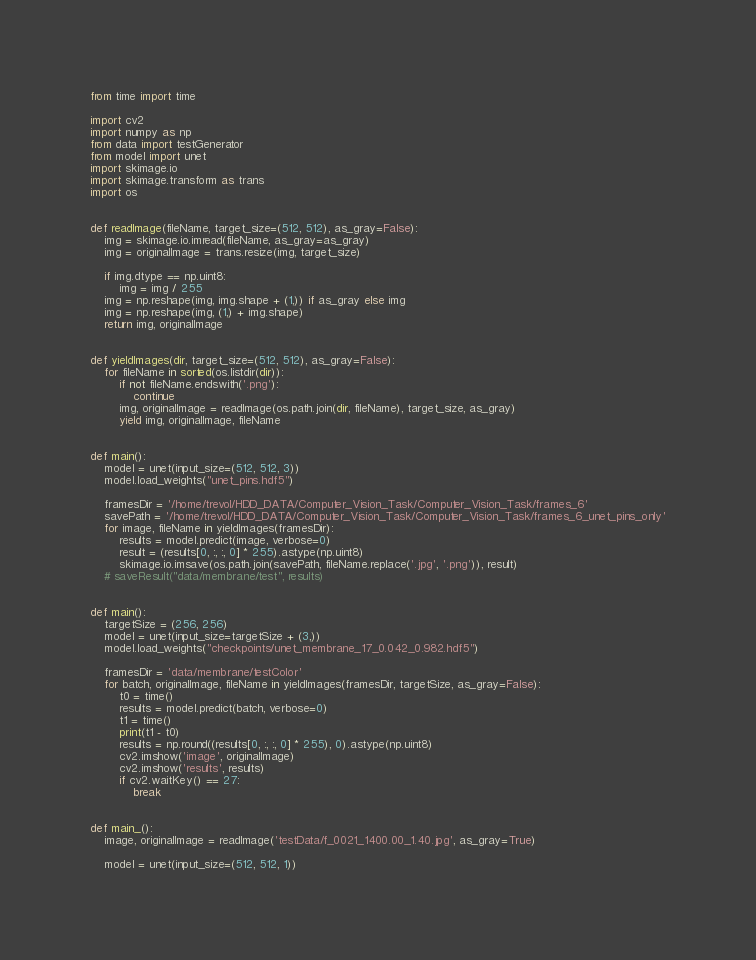Convert code to text. <code><loc_0><loc_0><loc_500><loc_500><_Python_>from time import time

import cv2
import numpy as np
from data import testGenerator
from model import unet
import skimage.io
import skimage.transform as trans
import os


def readImage(fileName, target_size=(512, 512), as_gray=False):
    img = skimage.io.imread(fileName, as_gray=as_gray)
    img = originalImage = trans.resize(img, target_size)

    if img.dtype == np.uint8:
        img = img / 255
    img = np.reshape(img, img.shape + (1,)) if as_gray else img
    img = np.reshape(img, (1,) + img.shape)
    return img, originalImage


def yieldImages(dir, target_size=(512, 512), as_gray=False):
    for fileName in sorted(os.listdir(dir)):
        if not fileName.endswith('.png'):
            continue
        img, originalImage = readImage(os.path.join(dir, fileName), target_size, as_gray)
        yield img, originalImage, fileName


def main():
    model = unet(input_size=(512, 512, 3))
    model.load_weights("unet_pins.hdf5")

    framesDir = '/home/trevol/HDD_DATA/Computer_Vision_Task/Computer_Vision_Task/frames_6'
    savePath = '/home/trevol/HDD_DATA/Computer_Vision_Task/Computer_Vision_Task/frames_6_unet_pins_only'
    for image, fileName in yieldImages(framesDir):
        results = model.predict(image, verbose=0)
        result = (results[0, :, :, 0] * 255).astype(np.uint8)
        skimage.io.imsave(os.path.join(savePath, fileName.replace('.jpg', '.png')), result)
    # saveResult("data/membrane/test", results)


def main():
    targetSize = (256, 256)
    model = unet(input_size=targetSize + (3,))
    model.load_weights("checkpoints/unet_membrane_17_0.042_0.982.hdf5")

    framesDir = 'data/membrane/testColor'
    for batch, originalImage, fileName in yieldImages(framesDir, targetSize, as_gray=False):
        t0 = time()
        results = model.predict(batch, verbose=0)
        t1 = time()
        print(t1 - t0)
        results = np.round((results[0, :, :, 0] * 255), 0).astype(np.uint8)
        cv2.imshow('image', originalImage)
        cv2.imshow('results', results)
        if cv2.waitKey() == 27:
            break


def main_():
    image, originalImage = readImage('testData/f_0021_1400.00_1.40.jpg', as_gray=True)

    model = unet(input_size=(512, 512, 1))</code> 